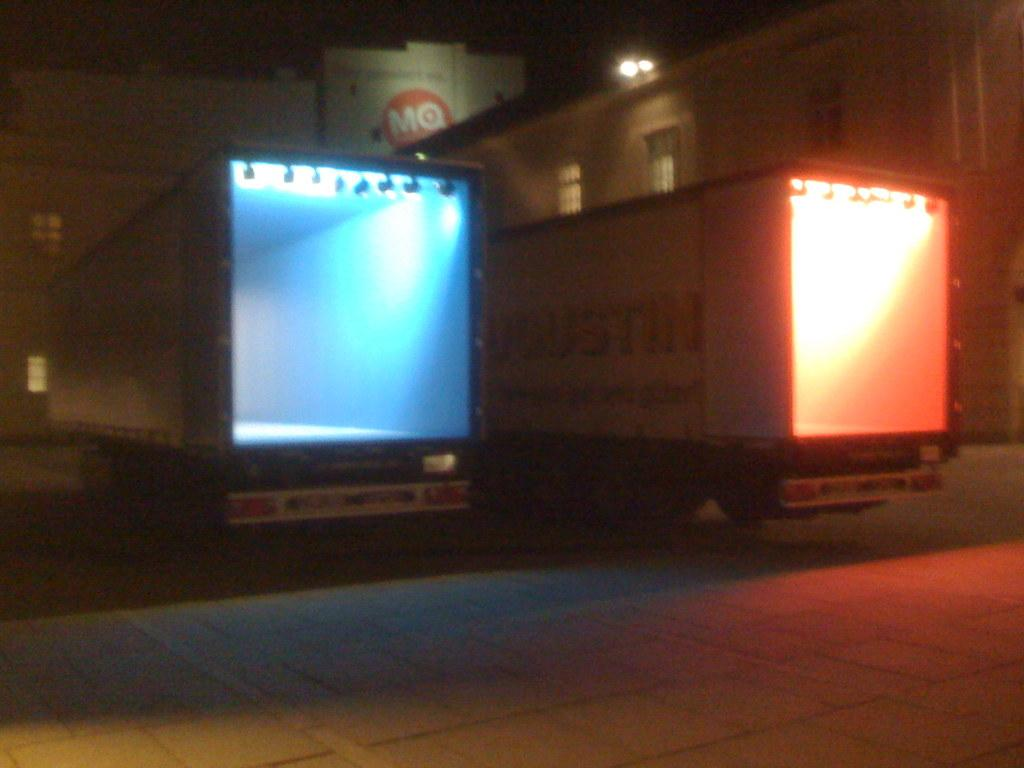<image>
Summarize the visual content of the image. Two large trucks are parked in front of a building with the letters MQ on it. 